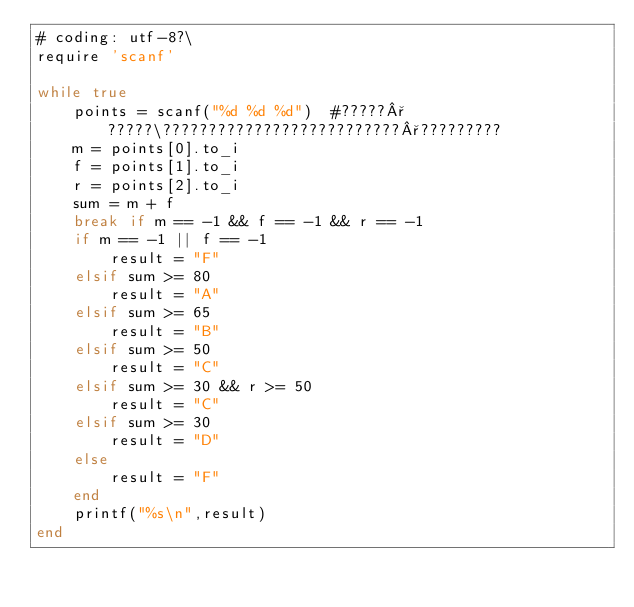Convert code to text. <code><loc_0><loc_0><loc_500><loc_500><_Ruby_># coding: utf-8?\
require 'scanf'

while true
	points = scanf("%d %d %d")	#?????°?????\??????????????????????????°?????????
	m = points[0].to_i
	f = points[1].to_i
	r = points[2].to_i
	sum = m + f
	break if m == -1 && f == -1 && r == -1
	if m == -1 || f == -1
		result = "F"
	elsif sum >= 80
		result = "A"
	elsif sum >= 65 
		result = "B"
	elsif sum >= 50
		result = "C"
	elsif sum >= 30 && r >= 50
		result = "C"
	elsif sum >= 30
		result = "D"
	else 
		result = "F"
	end
	printf("%s\n",result)
end</code> 